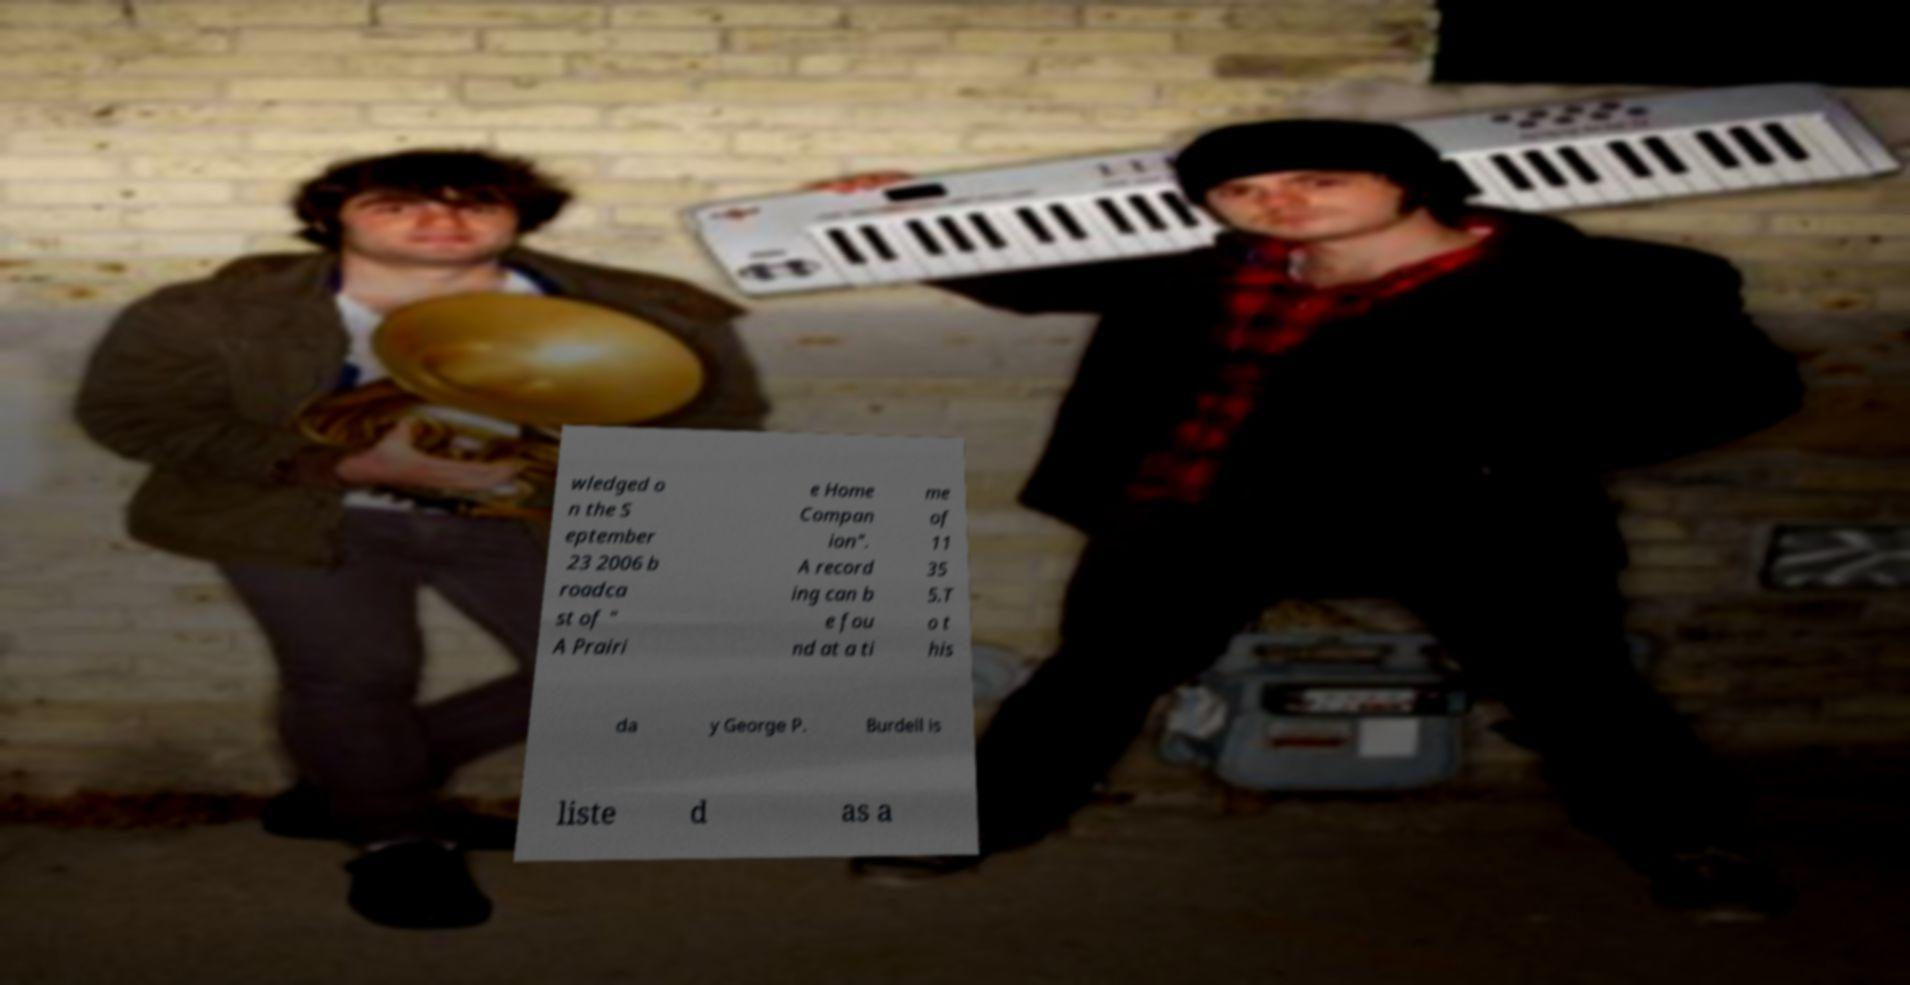Can you accurately transcribe the text from the provided image for me? wledged o n the S eptember 23 2006 b roadca st of " A Prairi e Home Compan ion". A record ing can b e fou nd at a ti me of 11 35 5.T o t his da y George P. Burdell is liste d as a 